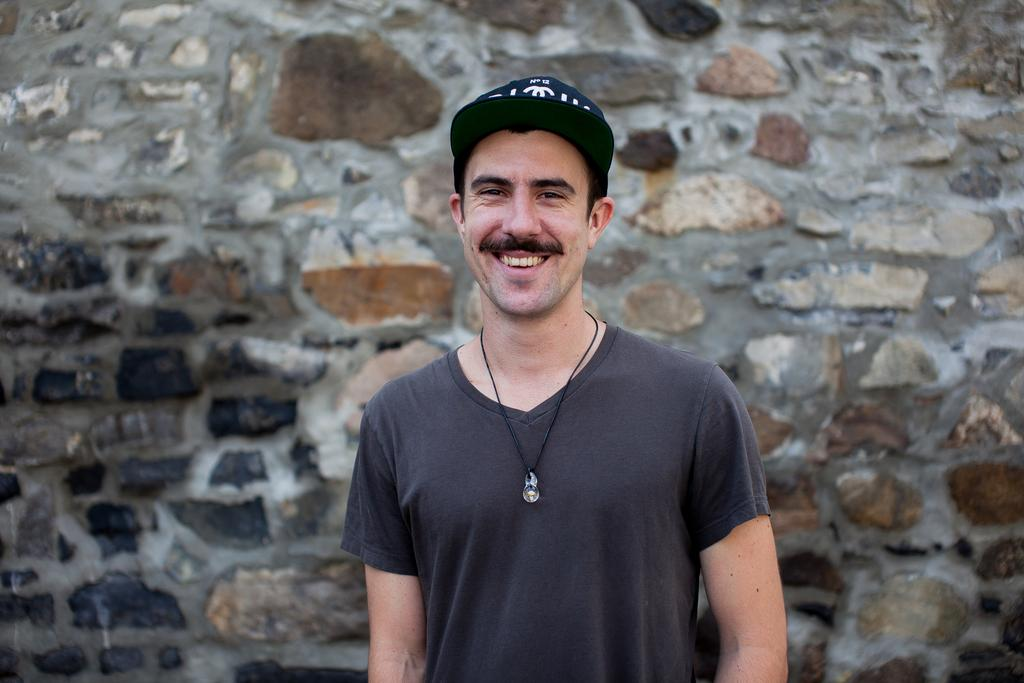What can be seen in the image? There is a person in the image. What is the person wearing? The person is wearing a t-shirt and a cap. What is the person doing? The person is watching something and smiling. What can be seen in the background of the image? There is a stone wall in the background of the image. What news is the person washing in the image? There is no news or washing activity present in the image. The person is simply watching something and smiling. 